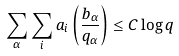Convert formula to latex. <formula><loc_0><loc_0><loc_500><loc_500>\sum _ { \alpha } \sum _ { i } a _ { i } \left ( \frac { b _ { \alpha } } { q _ { \alpha } } \right ) \leq C \log q</formula> 